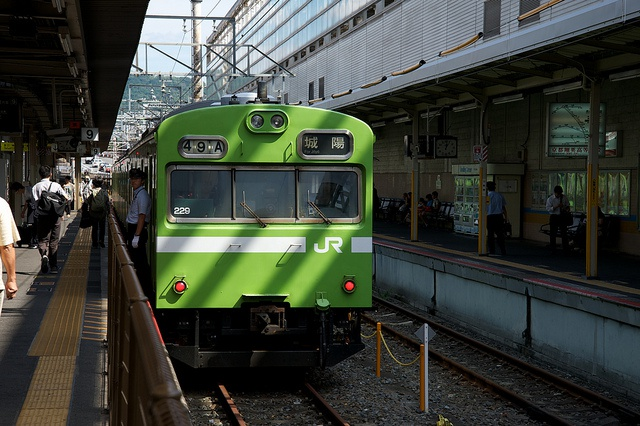Describe the objects in this image and their specific colors. I can see train in black, darkgreen, gray, and lightgreen tones, people in black, white, gray, and darkgray tones, people in black, gray, and darkblue tones, people in black, ivory, tan, and brown tones, and people in black, navy, and blue tones in this image. 